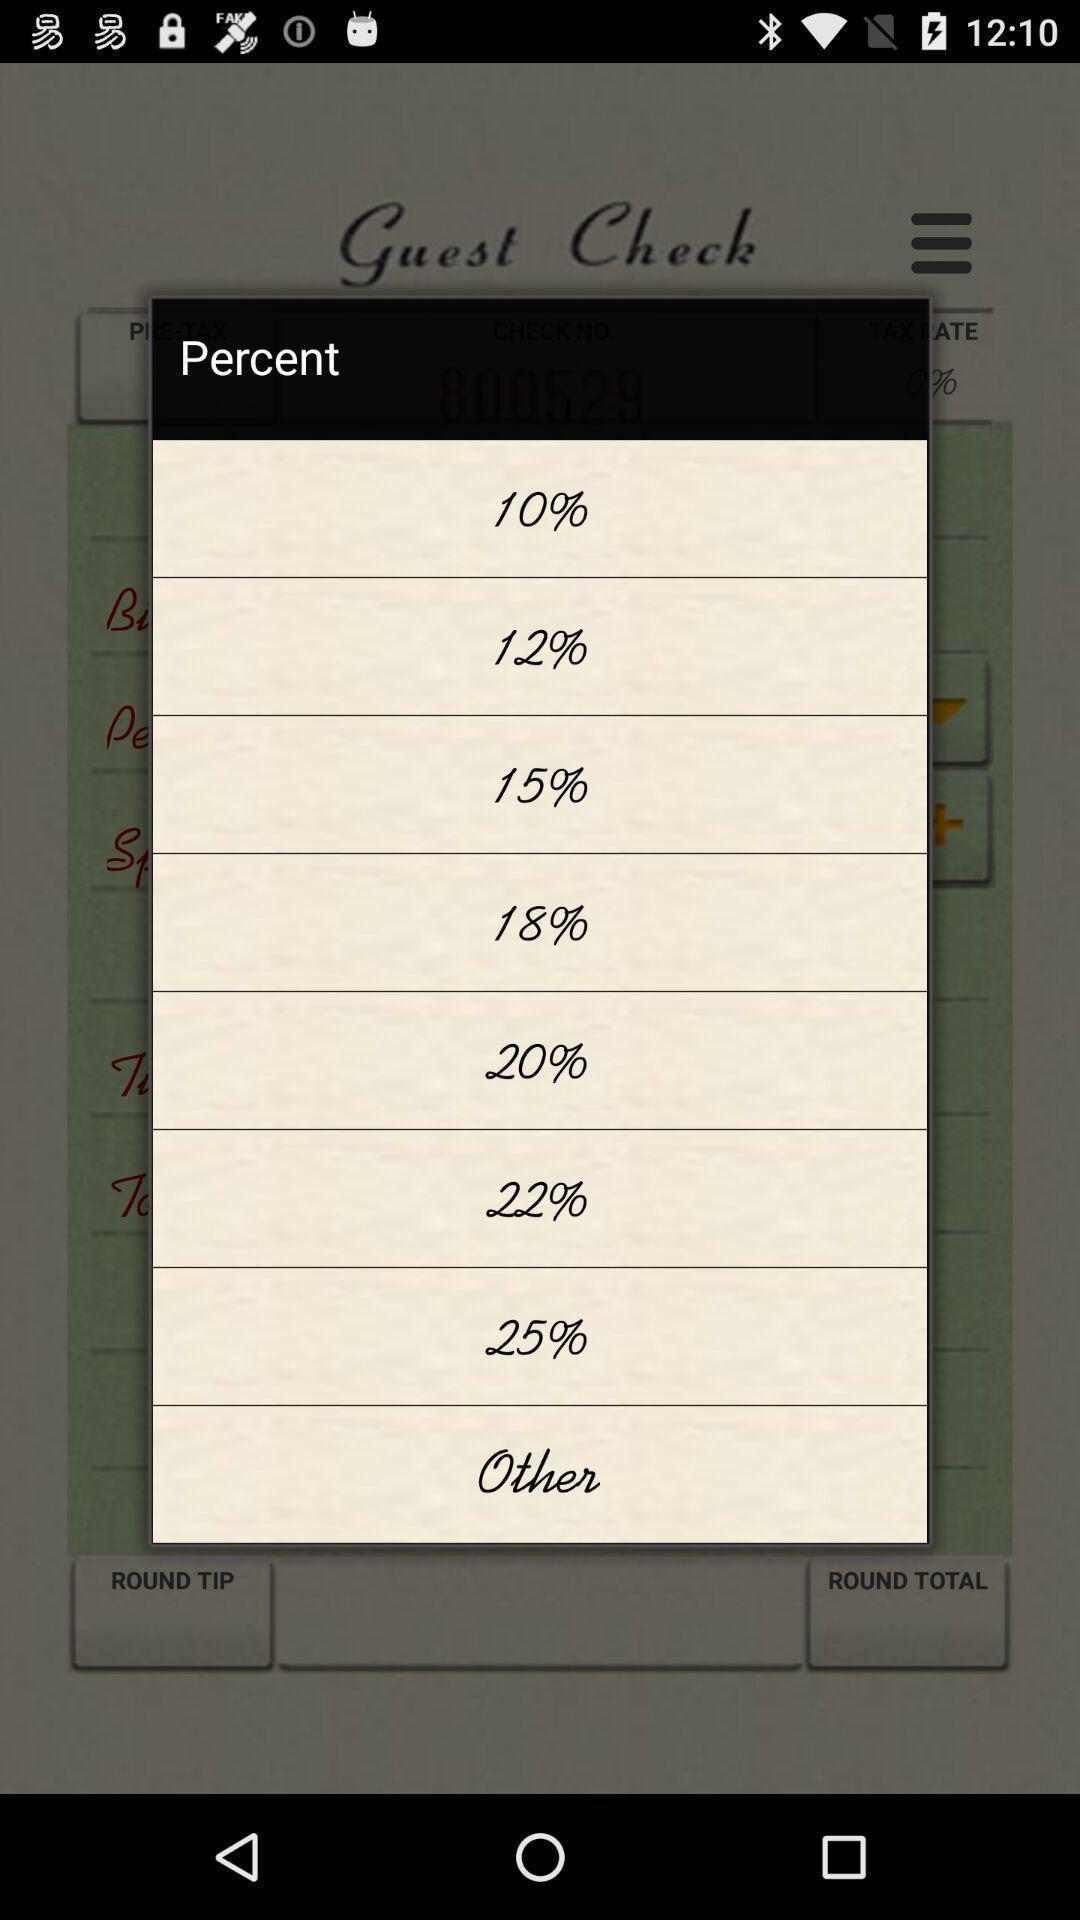Describe the visual elements of this screenshot. Showing percentage popup of a tip calculator app. 